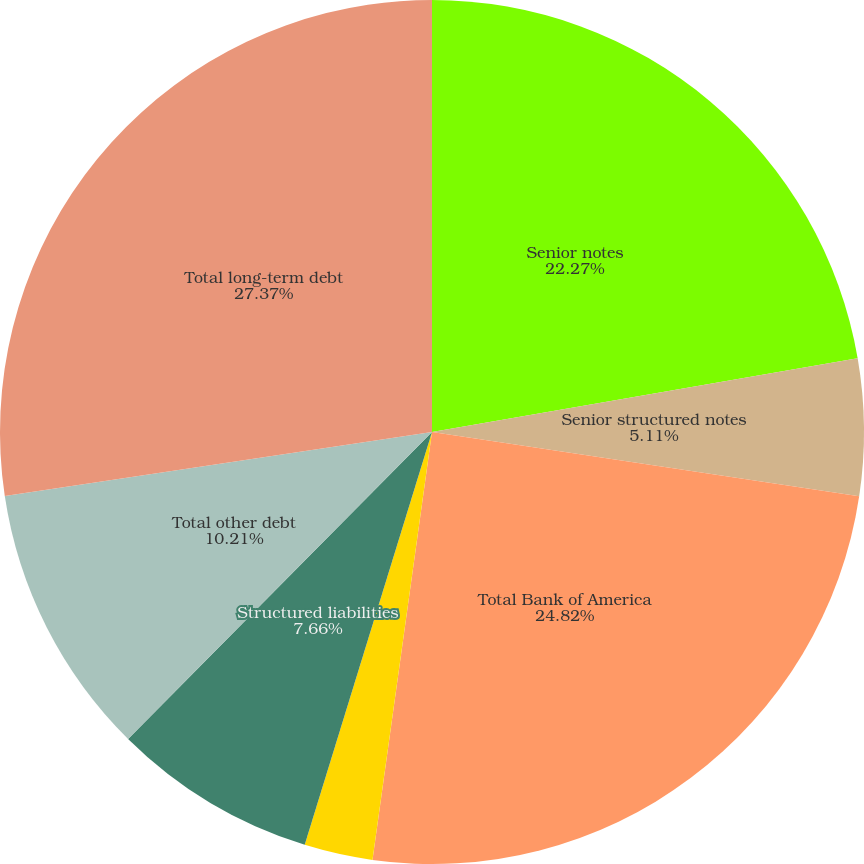<chart> <loc_0><loc_0><loc_500><loc_500><pie_chart><fcel>Senior notes<fcel>Senior structured notes<fcel>Total Bank of America<fcel>Advances from Federal Home<fcel>Total Bank of America NA<fcel>Structured liabilities<fcel>Total other debt<fcel>Total long-term debt<nl><fcel>22.27%<fcel>5.11%<fcel>24.82%<fcel>0.0%<fcel>2.56%<fcel>7.66%<fcel>10.21%<fcel>27.37%<nl></chart> 